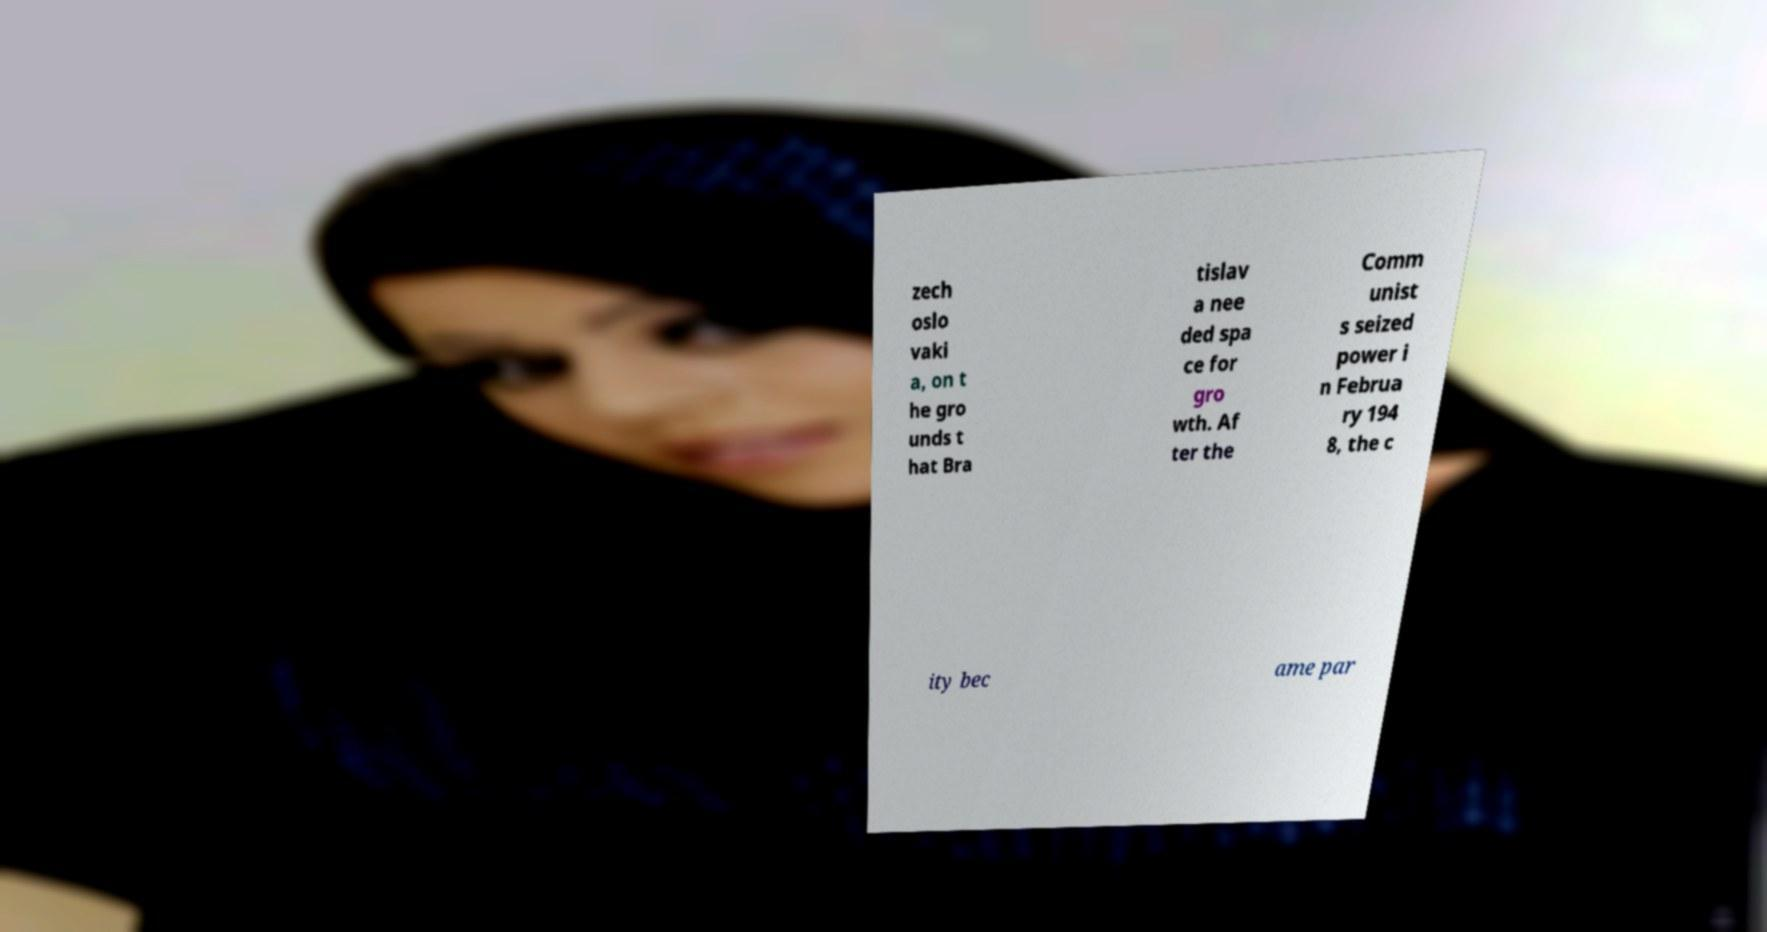Please read and relay the text visible in this image. What does it say? zech oslo vaki a, on t he gro unds t hat Bra tislav a nee ded spa ce for gro wth. Af ter the Comm unist s seized power i n Februa ry 194 8, the c ity bec ame par 